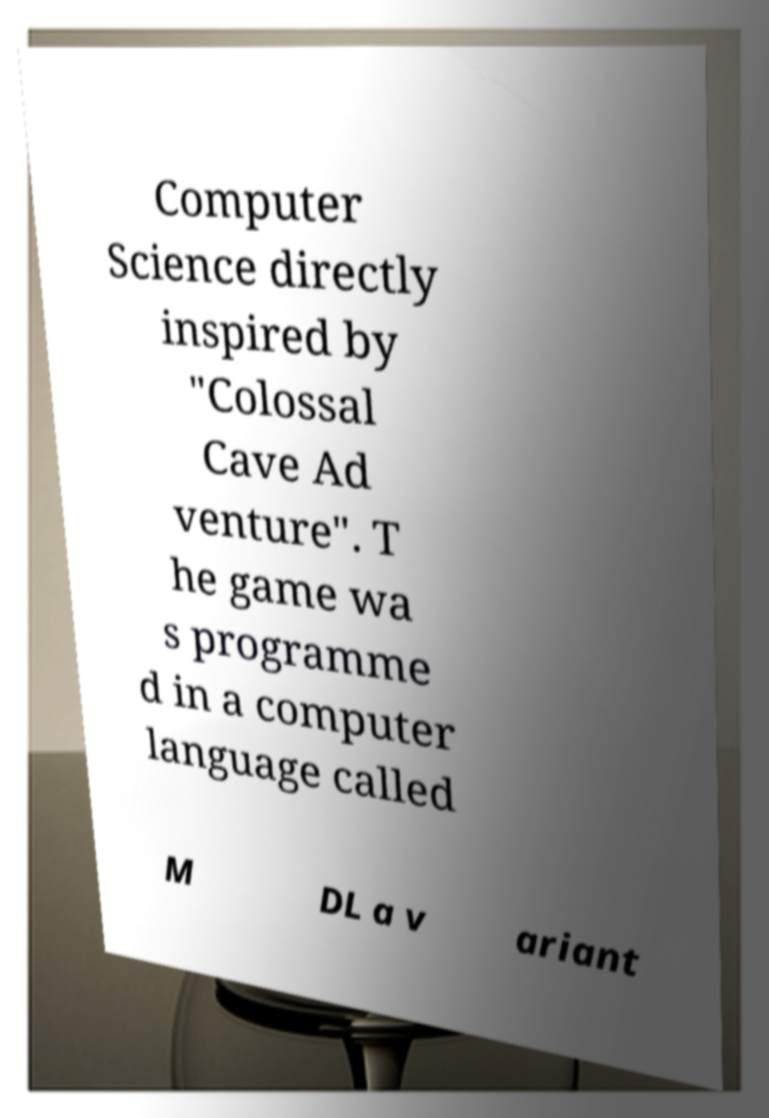For documentation purposes, I need the text within this image transcribed. Could you provide that? Computer Science directly inspired by "Colossal Cave Ad venture". T he game wa s programme d in a computer language called M DL a v ariant 